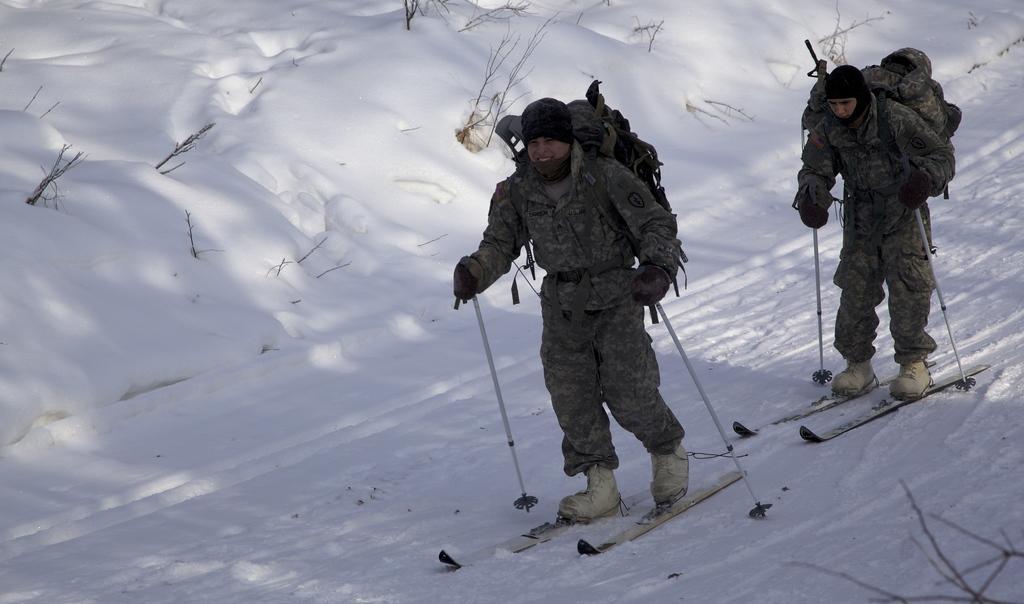Could you give a brief overview of what you see in this image? In the picture we can see two persons wearing backpacks and skiing. At the bottom we can see stems and snow. At the top there are plants and snow. 